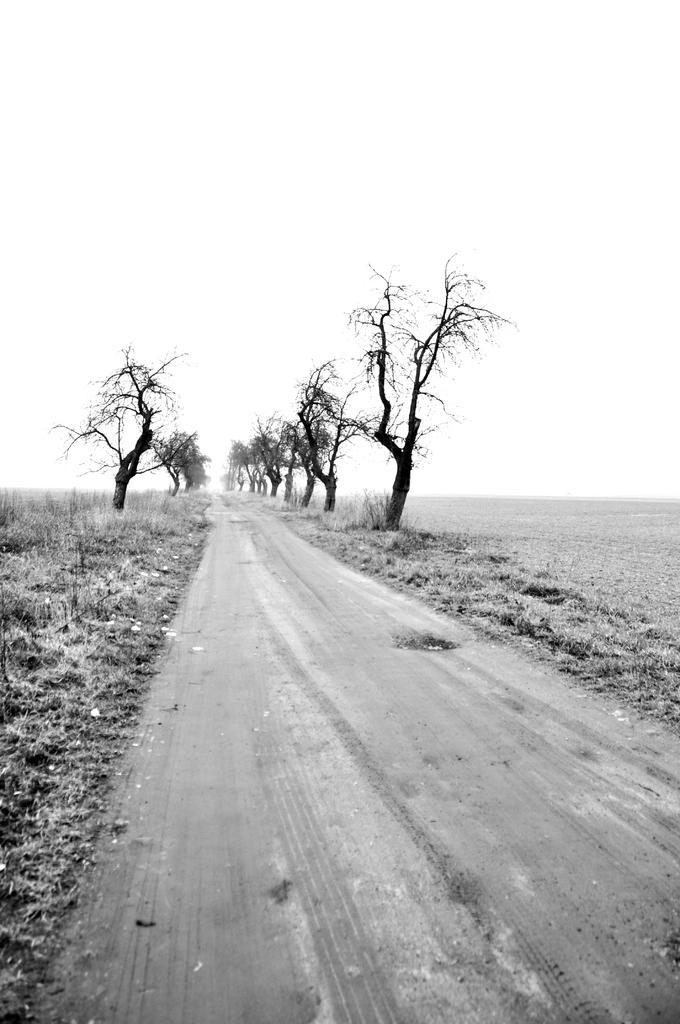How would you summarize this image in a sentence or two? This is a black and white image. In the center of the image we can see trees. At the bottom of the image we can see grass, road. At the top of the image there is a sky. 